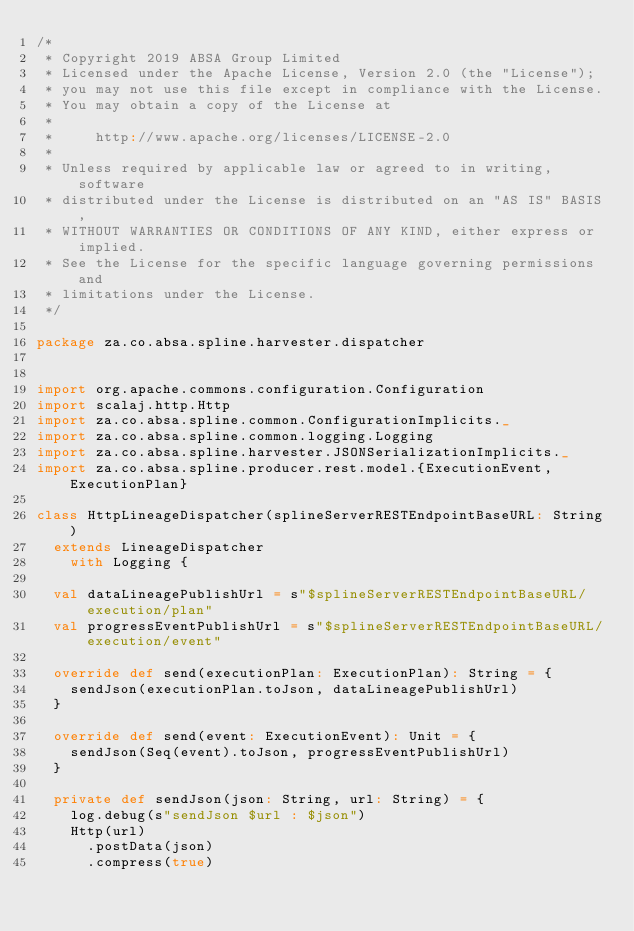Convert code to text. <code><loc_0><loc_0><loc_500><loc_500><_Scala_>/*
 * Copyright 2019 ABSA Group Limited
 * Licensed under the Apache License, Version 2.0 (the "License");
 * you may not use this file except in compliance with the License.
 * You may obtain a copy of the License at
 *
 *     http://www.apache.org/licenses/LICENSE-2.0
 *
 * Unless required by applicable law or agreed to in writing, software
 * distributed under the License is distributed on an "AS IS" BASIS,
 * WITHOUT WARRANTIES OR CONDITIONS OF ANY KIND, either express or implied.
 * See the License for the specific language governing permissions and
 * limitations under the License.
 */

package za.co.absa.spline.harvester.dispatcher


import org.apache.commons.configuration.Configuration
import scalaj.http.Http
import za.co.absa.spline.common.ConfigurationImplicits._
import za.co.absa.spline.common.logging.Logging
import za.co.absa.spline.harvester.JSONSerializationImplicits._
import za.co.absa.spline.producer.rest.model.{ExecutionEvent, ExecutionPlan}

class HttpLineageDispatcher(splineServerRESTEndpointBaseURL: String)
  extends LineageDispatcher
    with Logging {

  val dataLineagePublishUrl = s"$splineServerRESTEndpointBaseURL/execution/plan"
  val progressEventPublishUrl = s"$splineServerRESTEndpointBaseURL/execution/event"

  override def send(executionPlan: ExecutionPlan): String = {
    sendJson(executionPlan.toJson, dataLineagePublishUrl)
  }

  override def send(event: ExecutionEvent): Unit = {
    sendJson(Seq(event).toJson, progressEventPublishUrl)
  }

  private def sendJson(json: String, url: String) = {
    log.debug(s"sendJson $url : $json")
    Http(url)
      .postData(json)
      .compress(true)</code> 